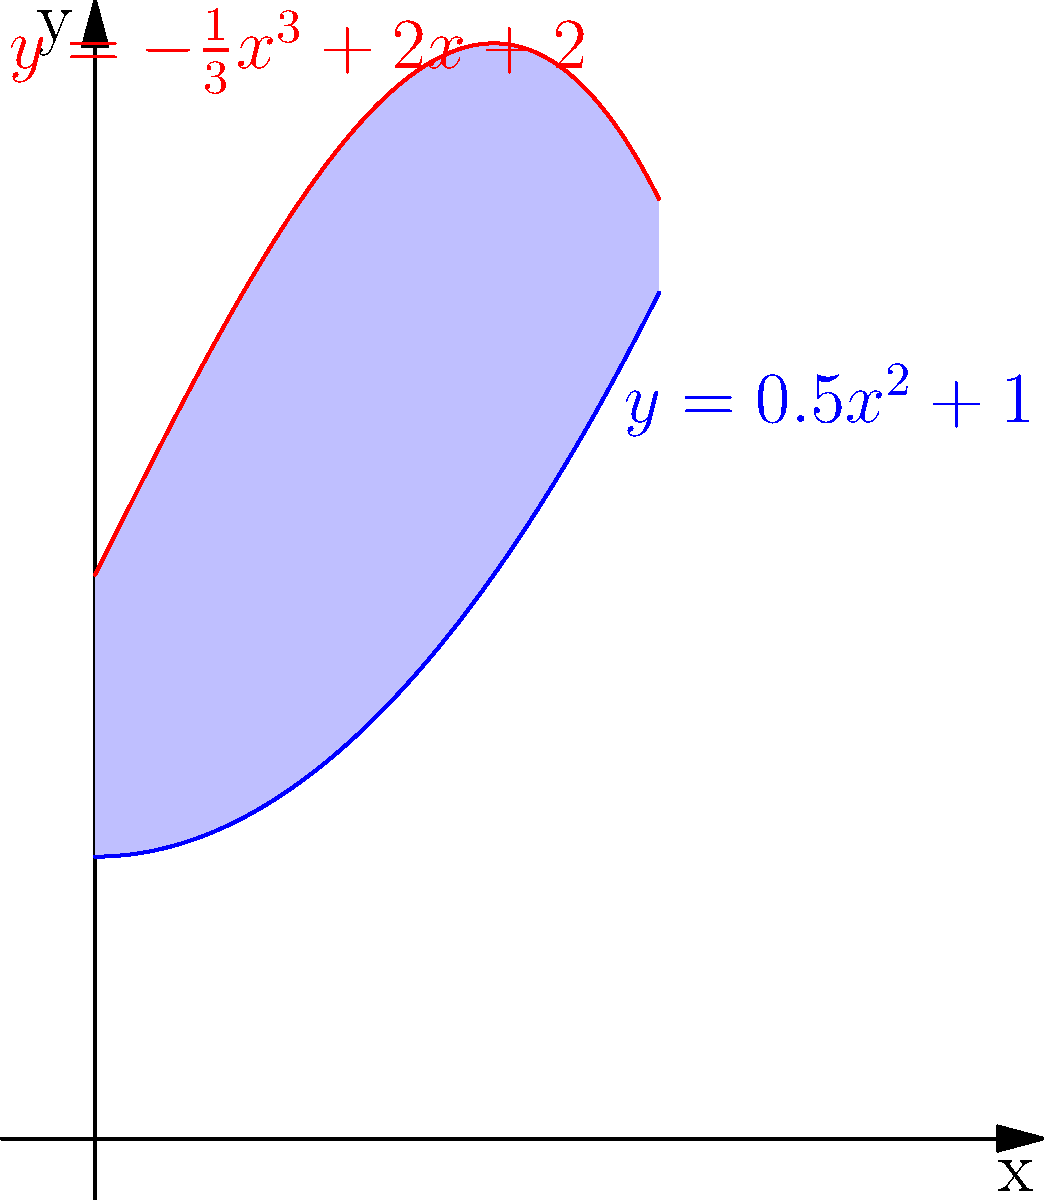In a study on the cultural significance of the Niqab, researchers plotted two curves representing different aspects of its social impact. The blue curve is given by $y=0.5x^2+1$, and the red curve by $y=-\frac{1}{3}x^3+2x+2$, where $x$ represents years since the study began and $y$ represents a measure of social impact. Calculate the area between these two curves from $x=0$ to $x=2$. To find the area between the two curves, we need to:

1) Identify the upper and lower functions:
   Upper: $g(x) = -\frac{1}{3}x^3+2x+2$
   Lower: $f(x) = 0.5x^2+1$

2) Set up the integral:
   Area = $\int_0^2 [g(x) - f(x)] dx$

3) Expand the integrand:
   $\int_0^2 [(-\frac{1}{3}x^3+2x+2) - (0.5x^2+1)] dx$
   $= \int_0^2 (-\frac{1}{3}x^3-0.5x^2+2x+1) dx$

4) Integrate:
   $= [-\frac{1}{12}x^4 - \frac{1}{6}x^3 + x^2 + x]_0^2$

5) Evaluate the bounds:
   $= (-\frac{1}{12}(16) - \frac{1}{6}(8) + 4 + 2) - (0)$
   $= (-\frac{4}{3} - \frac{4}{3} + 6)$
   $= \frac{10}{3}$

Therefore, the area between the curves from $x=0$ to $x=2$ is $\frac{10}{3}$ square units.
Answer: $\frac{10}{3}$ square units 